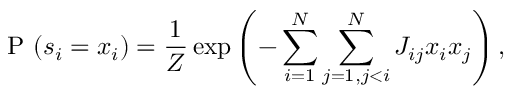<formula> <loc_0><loc_0><loc_500><loc_500>P ( s _ { i } = x _ { i } ) = \frac { 1 } { Z } \exp \left ( - \sum _ { i = 1 } ^ { N } \sum _ { j = 1 , j < i } ^ { N } J _ { i j } x _ { i } x _ { j } \right ) ,</formula> 